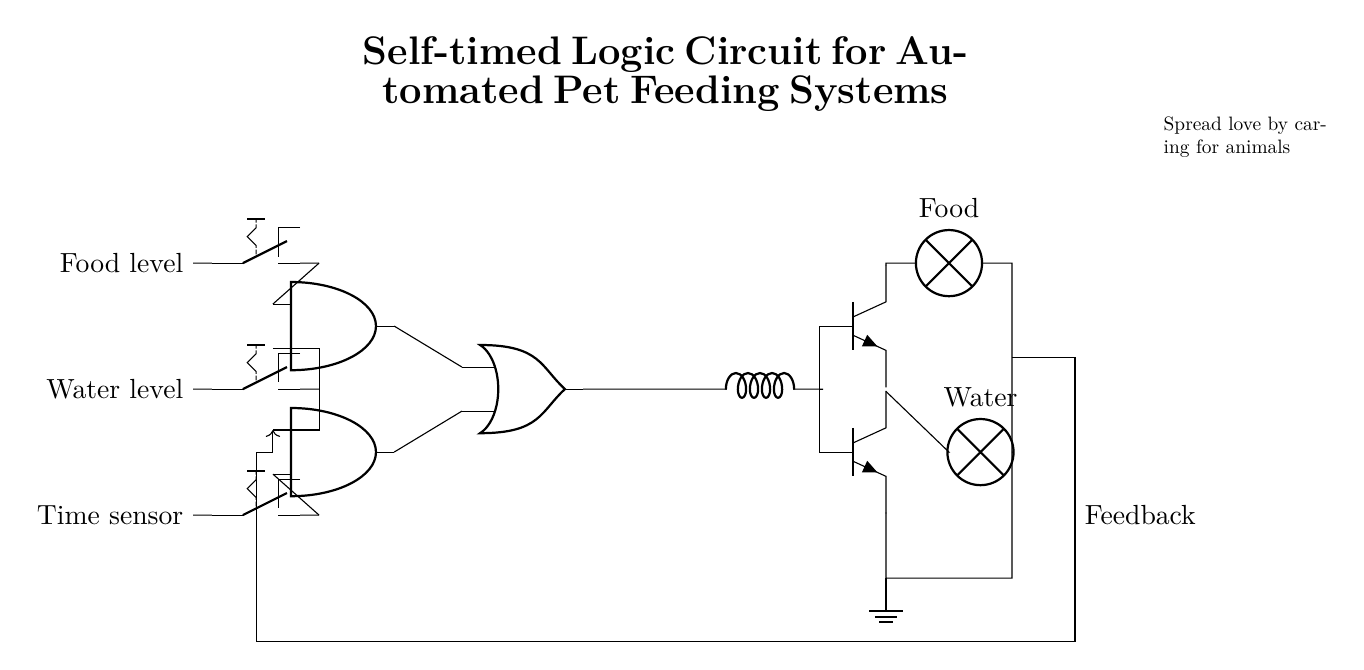What type of circuit is depicted? The circuit is a self-timed logic circuit, characterized by the presence of delays and conditions based on sensor inputs. It automates pet feeding by managing food and water levels.
Answer: self-timed logic circuit How many AND gates are present in the circuit? There are two AND gates in the circuit, identifiable by their 'and port' symbols. The diagram clearly shows both components located at separate vertical positions.
Answer: 2 What do the toggle switches represent? The toggle switches are sensors for food level, water level, and time sensor, which provide inputs to the logical operations of the circuit. Each switch controls a specific condition necessary for feeding automation.
Answer: sensors What component delays the output signal to the drivers? The inductor serves as the delay element, as it is connected to the output of the OR gate before the signal reaches the output drivers. It shapes the timing for the feeding mechanism.
Answer: inductor Which outputs are activated by the circuit? The outputs activated by the circuit are food and water, represented by the lamps in the diagram indicating the actions to be taken based on the logic conditions.
Answer: food and water What is the role of the feedback connection in this circuit? The feedback connection ensures that the circuit can adjust the feeding operations based on previous outputs, maintaining an appropriate balance of available resources for the animals. This feedback loop interacts with one of the AND gates to influence the feeding trigger.
Answer: adjust feeding operations 